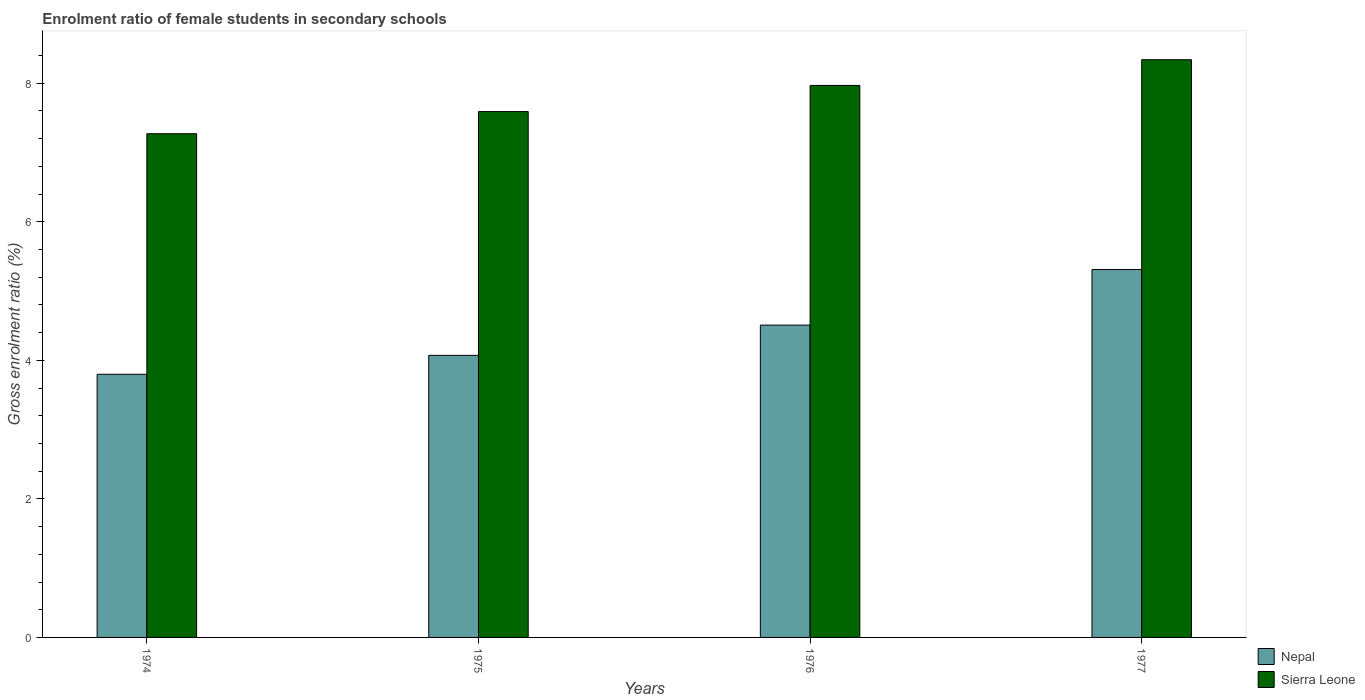Are the number of bars per tick equal to the number of legend labels?
Your answer should be compact. Yes. Are the number of bars on each tick of the X-axis equal?
Offer a terse response. Yes. How many bars are there on the 2nd tick from the right?
Give a very brief answer. 2. In how many cases, is the number of bars for a given year not equal to the number of legend labels?
Offer a terse response. 0. What is the enrolment ratio of female students in secondary schools in Nepal in 1976?
Your response must be concise. 4.51. Across all years, what is the maximum enrolment ratio of female students in secondary schools in Sierra Leone?
Your answer should be very brief. 8.34. Across all years, what is the minimum enrolment ratio of female students in secondary schools in Sierra Leone?
Give a very brief answer. 7.27. In which year was the enrolment ratio of female students in secondary schools in Nepal minimum?
Make the answer very short. 1974. What is the total enrolment ratio of female students in secondary schools in Sierra Leone in the graph?
Your answer should be very brief. 31.17. What is the difference between the enrolment ratio of female students in secondary schools in Sierra Leone in 1975 and that in 1976?
Keep it short and to the point. -0.38. What is the difference between the enrolment ratio of female students in secondary schools in Sierra Leone in 1975 and the enrolment ratio of female students in secondary schools in Nepal in 1977?
Provide a short and direct response. 2.28. What is the average enrolment ratio of female students in secondary schools in Nepal per year?
Provide a succinct answer. 4.42. In the year 1975, what is the difference between the enrolment ratio of female students in secondary schools in Nepal and enrolment ratio of female students in secondary schools in Sierra Leone?
Your answer should be compact. -3.52. What is the ratio of the enrolment ratio of female students in secondary schools in Sierra Leone in 1975 to that in 1977?
Give a very brief answer. 0.91. What is the difference between the highest and the second highest enrolment ratio of female students in secondary schools in Sierra Leone?
Offer a terse response. 0.37. What is the difference between the highest and the lowest enrolment ratio of female students in secondary schools in Nepal?
Keep it short and to the point. 1.51. What does the 2nd bar from the left in 1975 represents?
Keep it short and to the point. Sierra Leone. What does the 2nd bar from the right in 1976 represents?
Give a very brief answer. Nepal. How many years are there in the graph?
Give a very brief answer. 4. What is the difference between two consecutive major ticks on the Y-axis?
Give a very brief answer. 2. Are the values on the major ticks of Y-axis written in scientific E-notation?
Offer a terse response. No. Where does the legend appear in the graph?
Give a very brief answer. Bottom right. How many legend labels are there?
Provide a short and direct response. 2. How are the legend labels stacked?
Offer a very short reply. Vertical. What is the title of the graph?
Provide a succinct answer. Enrolment ratio of female students in secondary schools. Does "Uruguay" appear as one of the legend labels in the graph?
Offer a very short reply. No. What is the label or title of the X-axis?
Offer a very short reply. Years. What is the label or title of the Y-axis?
Offer a terse response. Gross enrolment ratio (%). What is the Gross enrolment ratio (%) of Nepal in 1974?
Provide a short and direct response. 3.8. What is the Gross enrolment ratio (%) of Sierra Leone in 1974?
Your response must be concise. 7.27. What is the Gross enrolment ratio (%) of Nepal in 1975?
Offer a very short reply. 4.07. What is the Gross enrolment ratio (%) in Sierra Leone in 1975?
Provide a short and direct response. 7.59. What is the Gross enrolment ratio (%) in Nepal in 1976?
Your answer should be very brief. 4.51. What is the Gross enrolment ratio (%) in Sierra Leone in 1976?
Offer a terse response. 7.97. What is the Gross enrolment ratio (%) in Nepal in 1977?
Offer a very short reply. 5.31. What is the Gross enrolment ratio (%) in Sierra Leone in 1977?
Provide a short and direct response. 8.34. Across all years, what is the maximum Gross enrolment ratio (%) of Nepal?
Provide a succinct answer. 5.31. Across all years, what is the maximum Gross enrolment ratio (%) of Sierra Leone?
Give a very brief answer. 8.34. Across all years, what is the minimum Gross enrolment ratio (%) of Nepal?
Your response must be concise. 3.8. Across all years, what is the minimum Gross enrolment ratio (%) in Sierra Leone?
Your answer should be very brief. 7.27. What is the total Gross enrolment ratio (%) of Nepal in the graph?
Offer a very short reply. 17.69. What is the total Gross enrolment ratio (%) of Sierra Leone in the graph?
Keep it short and to the point. 31.17. What is the difference between the Gross enrolment ratio (%) of Nepal in 1974 and that in 1975?
Give a very brief answer. -0.27. What is the difference between the Gross enrolment ratio (%) in Sierra Leone in 1974 and that in 1975?
Keep it short and to the point. -0.32. What is the difference between the Gross enrolment ratio (%) in Nepal in 1974 and that in 1976?
Your response must be concise. -0.71. What is the difference between the Gross enrolment ratio (%) in Sierra Leone in 1974 and that in 1976?
Provide a succinct answer. -0.7. What is the difference between the Gross enrolment ratio (%) in Nepal in 1974 and that in 1977?
Offer a terse response. -1.51. What is the difference between the Gross enrolment ratio (%) in Sierra Leone in 1974 and that in 1977?
Provide a succinct answer. -1.07. What is the difference between the Gross enrolment ratio (%) of Nepal in 1975 and that in 1976?
Your answer should be very brief. -0.44. What is the difference between the Gross enrolment ratio (%) in Sierra Leone in 1975 and that in 1976?
Your answer should be compact. -0.38. What is the difference between the Gross enrolment ratio (%) of Nepal in 1975 and that in 1977?
Keep it short and to the point. -1.24. What is the difference between the Gross enrolment ratio (%) of Sierra Leone in 1975 and that in 1977?
Keep it short and to the point. -0.75. What is the difference between the Gross enrolment ratio (%) in Nepal in 1976 and that in 1977?
Keep it short and to the point. -0.8. What is the difference between the Gross enrolment ratio (%) in Sierra Leone in 1976 and that in 1977?
Your response must be concise. -0.37. What is the difference between the Gross enrolment ratio (%) of Nepal in 1974 and the Gross enrolment ratio (%) of Sierra Leone in 1975?
Your answer should be very brief. -3.79. What is the difference between the Gross enrolment ratio (%) in Nepal in 1974 and the Gross enrolment ratio (%) in Sierra Leone in 1976?
Provide a short and direct response. -4.17. What is the difference between the Gross enrolment ratio (%) in Nepal in 1974 and the Gross enrolment ratio (%) in Sierra Leone in 1977?
Your answer should be very brief. -4.54. What is the difference between the Gross enrolment ratio (%) of Nepal in 1975 and the Gross enrolment ratio (%) of Sierra Leone in 1976?
Offer a very short reply. -3.9. What is the difference between the Gross enrolment ratio (%) of Nepal in 1975 and the Gross enrolment ratio (%) of Sierra Leone in 1977?
Keep it short and to the point. -4.27. What is the difference between the Gross enrolment ratio (%) of Nepal in 1976 and the Gross enrolment ratio (%) of Sierra Leone in 1977?
Your answer should be compact. -3.83. What is the average Gross enrolment ratio (%) in Nepal per year?
Provide a short and direct response. 4.42. What is the average Gross enrolment ratio (%) in Sierra Leone per year?
Keep it short and to the point. 7.79. In the year 1974, what is the difference between the Gross enrolment ratio (%) of Nepal and Gross enrolment ratio (%) of Sierra Leone?
Provide a short and direct response. -3.47. In the year 1975, what is the difference between the Gross enrolment ratio (%) of Nepal and Gross enrolment ratio (%) of Sierra Leone?
Your answer should be very brief. -3.52. In the year 1976, what is the difference between the Gross enrolment ratio (%) in Nepal and Gross enrolment ratio (%) in Sierra Leone?
Ensure brevity in your answer.  -3.46. In the year 1977, what is the difference between the Gross enrolment ratio (%) of Nepal and Gross enrolment ratio (%) of Sierra Leone?
Offer a terse response. -3.03. What is the ratio of the Gross enrolment ratio (%) in Nepal in 1974 to that in 1975?
Offer a very short reply. 0.93. What is the ratio of the Gross enrolment ratio (%) of Sierra Leone in 1974 to that in 1975?
Provide a short and direct response. 0.96. What is the ratio of the Gross enrolment ratio (%) in Nepal in 1974 to that in 1976?
Provide a short and direct response. 0.84. What is the ratio of the Gross enrolment ratio (%) in Sierra Leone in 1974 to that in 1976?
Provide a succinct answer. 0.91. What is the ratio of the Gross enrolment ratio (%) in Nepal in 1974 to that in 1977?
Give a very brief answer. 0.72. What is the ratio of the Gross enrolment ratio (%) in Sierra Leone in 1974 to that in 1977?
Ensure brevity in your answer.  0.87. What is the ratio of the Gross enrolment ratio (%) in Nepal in 1975 to that in 1976?
Provide a short and direct response. 0.9. What is the ratio of the Gross enrolment ratio (%) of Sierra Leone in 1975 to that in 1976?
Your answer should be very brief. 0.95. What is the ratio of the Gross enrolment ratio (%) of Nepal in 1975 to that in 1977?
Keep it short and to the point. 0.77. What is the ratio of the Gross enrolment ratio (%) of Sierra Leone in 1975 to that in 1977?
Give a very brief answer. 0.91. What is the ratio of the Gross enrolment ratio (%) of Nepal in 1976 to that in 1977?
Provide a succinct answer. 0.85. What is the ratio of the Gross enrolment ratio (%) of Sierra Leone in 1976 to that in 1977?
Give a very brief answer. 0.96. What is the difference between the highest and the second highest Gross enrolment ratio (%) of Nepal?
Your answer should be compact. 0.8. What is the difference between the highest and the second highest Gross enrolment ratio (%) of Sierra Leone?
Make the answer very short. 0.37. What is the difference between the highest and the lowest Gross enrolment ratio (%) in Nepal?
Make the answer very short. 1.51. What is the difference between the highest and the lowest Gross enrolment ratio (%) in Sierra Leone?
Your response must be concise. 1.07. 